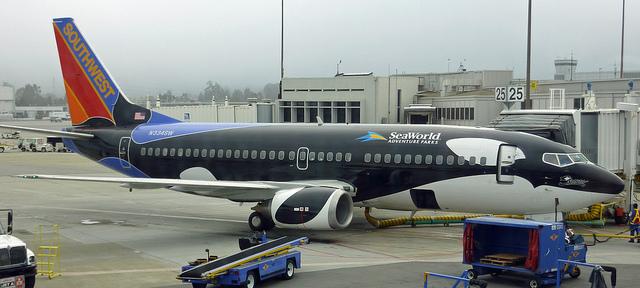What is the plane written?
Write a very short answer. Seaworld. What color is the plane?
Short answer required. Black and white. What is the main color of this plane?
Be succinct. Black. Is it sunny outside?
Short answer required. No. 